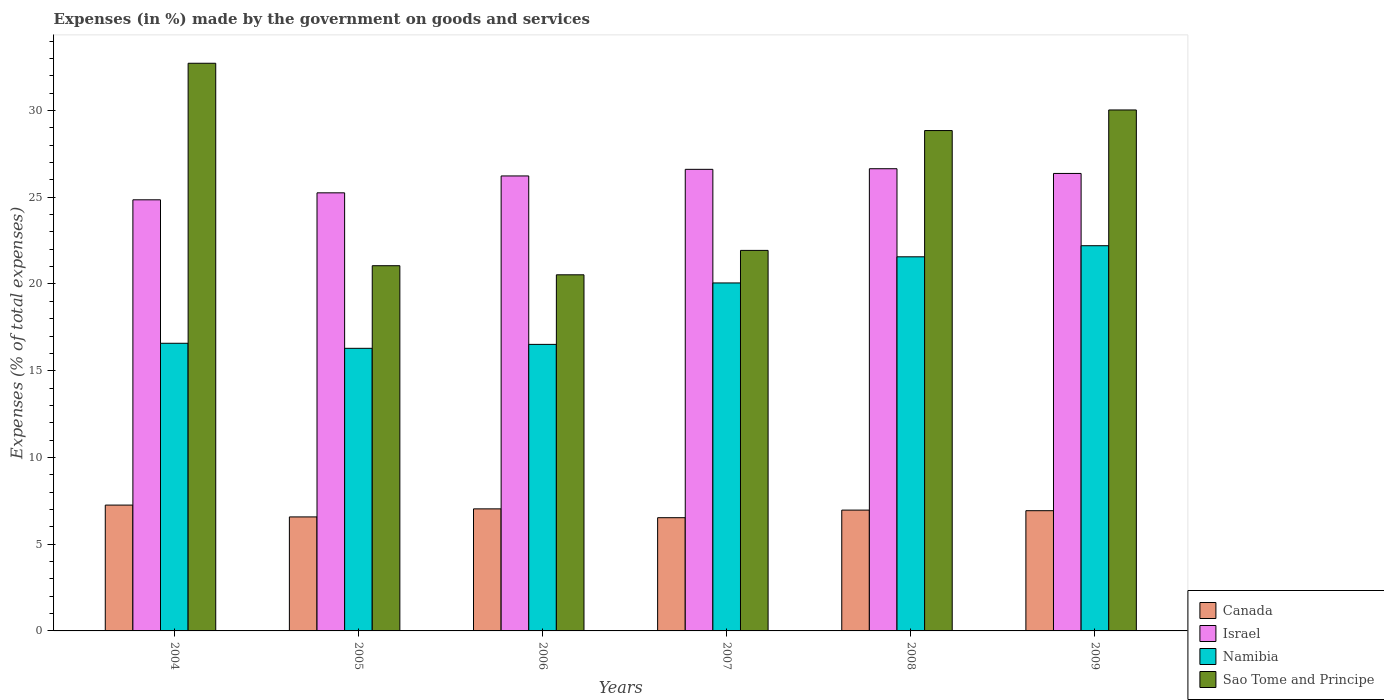How many different coloured bars are there?
Make the answer very short. 4. How many groups of bars are there?
Offer a terse response. 6. Are the number of bars per tick equal to the number of legend labels?
Offer a terse response. Yes. Are the number of bars on each tick of the X-axis equal?
Offer a terse response. Yes. How many bars are there on the 5th tick from the left?
Your answer should be compact. 4. What is the percentage of expenses made by the government on goods and services in Namibia in 2006?
Give a very brief answer. 16.52. Across all years, what is the maximum percentage of expenses made by the government on goods and services in Israel?
Ensure brevity in your answer.  26.65. Across all years, what is the minimum percentage of expenses made by the government on goods and services in Israel?
Your answer should be compact. 24.85. In which year was the percentage of expenses made by the government on goods and services in Israel minimum?
Ensure brevity in your answer.  2004. What is the total percentage of expenses made by the government on goods and services in Namibia in the graph?
Make the answer very short. 113.23. What is the difference between the percentage of expenses made by the government on goods and services in Namibia in 2004 and that in 2005?
Your answer should be compact. 0.29. What is the difference between the percentage of expenses made by the government on goods and services in Israel in 2008 and the percentage of expenses made by the government on goods and services in Canada in 2004?
Offer a very short reply. 19.39. What is the average percentage of expenses made by the government on goods and services in Sao Tome and Principe per year?
Provide a short and direct response. 25.85. In the year 2009, what is the difference between the percentage of expenses made by the government on goods and services in Sao Tome and Principe and percentage of expenses made by the government on goods and services in Israel?
Your answer should be compact. 3.66. What is the ratio of the percentage of expenses made by the government on goods and services in Israel in 2006 to that in 2007?
Offer a terse response. 0.99. Is the difference between the percentage of expenses made by the government on goods and services in Sao Tome and Principe in 2004 and 2007 greater than the difference between the percentage of expenses made by the government on goods and services in Israel in 2004 and 2007?
Ensure brevity in your answer.  Yes. What is the difference between the highest and the second highest percentage of expenses made by the government on goods and services in Canada?
Provide a short and direct response. 0.22. What is the difference between the highest and the lowest percentage of expenses made by the government on goods and services in Canada?
Ensure brevity in your answer.  0.73. What does the 1st bar from the left in 2007 represents?
Make the answer very short. Canada. What does the 4th bar from the right in 2006 represents?
Offer a very short reply. Canada. Is it the case that in every year, the sum of the percentage of expenses made by the government on goods and services in Israel and percentage of expenses made by the government on goods and services in Canada is greater than the percentage of expenses made by the government on goods and services in Namibia?
Make the answer very short. Yes. How many bars are there?
Ensure brevity in your answer.  24. How many years are there in the graph?
Provide a short and direct response. 6. What is the difference between two consecutive major ticks on the Y-axis?
Offer a terse response. 5. Where does the legend appear in the graph?
Make the answer very short. Bottom right. How many legend labels are there?
Provide a succinct answer. 4. What is the title of the graph?
Provide a succinct answer. Expenses (in %) made by the government on goods and services. What is the label or title of the Y-axis?
Your answer should be very brief. Expenses (% of total expenses). What is the Expenses (% of total expenses) in Canada in 2004?
Keep it short and to the point. 7.25. What is the Expenses (% of total expenses) of Israel in 2004?
Ensure brevity in your answer.  24.85. What is the Expenses (% of total expenses) in Namibia in 2004?
Give a very brief answer. 16.58. What is the Expenses (% of total expenses) of Sao Tome and Principe in 2004?
Offer a very short reply. 32.73. What is the Expenses (% of total expenses) of Canada in 2005?
Provide a short and direct response. 6.57. What is the Expenses (% of total expenses) in Israel in 2005?
Make the answer very short. 25.26. What is the Expenses (% of total expenses) of Namibia in 2005?
Give a very brief answer. 16.29. What is the Expenses (% of total expenses) in Sao Tome and Principe in 2005?
Your answer should be compact. 21.05. What is the Expenses (% of total expenses) of Canada in 2006?
Offer a terse response. 7.04. What is the Expenses (% of total expenses) in Israel in 2006?
Offer a very short reply. 26.23. What is the Expenses (% of total expenses) of Namibia in 2006?
Give a very brief answer. 16.52. What is the Expenses (% of total expenses) of Sao Tome and Principe in 2006?
Offer a terse response. 20.53. What is the Expenses (% of total expenses) of Canada in 2007?
Offer a terse response. 6.53. What is the Expenses (% of total expenses) of Israel in 2007?
Offer a terse response. 26.61. What is the Expenses (% of total expenses) of Namibia in 2007?
Your answer should be very brief. 20.06. What is the Expenses (% of total expenses) of Sao Tome and Principe in 2007?
Offer a terse response. 21.94. What is the Expenses (% of total expenses) in Canada in 2008?
Provide a short and direct response. 6.97. What is the Expenses (% of total expenses) of Israel in 2008?
Provide a short and direct response. 26.65. What is the Expenses (% of total expenses) of Namibia in 2008?
Make the answer very short. 21.57. What is the Expenses (% of total expenses) in Sao Tome and Principe in 2008?
Your response must be concise. 28.85. What is the Expenses (% of total expenses) of Canada in 2009?
Ensure brevity in your answer.  6.93. What is the Expenses (% of total expenses) in Israel in 2009?
Keep it short and to the point. 26.37. What is the Expenses (% of total expenses) in Namibia in 2009?
Ensure brevity in your answer.  22.21. What is the Expenses (% of total expenses) in Sao Tome and Principe in 2009?
Your answer should be compact. 30.03. Across all years, what is the maximum Expenses (% of total expenses) in Canada?
Your answer should be compact. 7.25. Across all years, what is the maximum Expenses (% of total expenses) of Israel?
Make the answer very short. 26.65. Across all years, what is the maximum Expenses (% of total expenses) in Namibia?
Your answer should be very brief. 22.21. Across all years, what is the maximum Expenses (% of total expenses) of Sao Tome and Principe?
Your answer should be compact. 32.73. Across all years, what is the minimum Expenses (% of total expenses) of Canada?
Ensure brevity in your answer.  6.53. Across all years, what is the minimum Expenses (% of total expenses) of Israel?
Ensure brevity in your answer.  24.85. Across all years, what is the minimum Expenses (% of total expenses) of Namibia?
Provide a succinct answer. 16.29. Across all years, what is the minimum Expenses (% of total expenses) in Sao Tome and Principe?
Offer a very short reply. 20.53. What is the total Expenses (% of total expenses) of Canada in the graph?
Provide a short and direct response. 41.29. What is the total Expenses (% of total expenses) in Israel in the graph?
Offer a terse response. 155.97. What is the total Expenses (% of total expenses) of Namibia in the graph?
Your answer should be compact. 113.23. What is the total Expenses (% of total expenses) in Sao Tome and Principe in the graph?
Ensure brevity in your answer.  155.13. What is the difference between the Expenses (% of total expenses) of Canada in 2004 and that in 2005?
Provide a succinct answer. 0.68. What is the difference between the Expenses (% of total expenses) in Israel in 2004 and that in 2005?
Your answer should be very brief. -0.4. What is the difference between the Expenses (% of total expenses) of Namibia in 2004 and that in 2005?
Provide a succinct answer. 0.29. What is the difference between the Expenses (% of total expenses) of Sao Tome and Principe in 2004 and that in 2005?
Your answer should be very brief. 11.67. What is the difference between the Expenses (% of total expenses) of Canada in 2004 and that in 2006?
Keep it short and to the point. 0.22. What is the difference between the Expenses (% of total expenses) of Israel in 2004 and that in 2006?
Provide a short and direct response. -1.38. What is the difference between the Expenses (% of total expenses) of Namibia in 2004 and that in 2006?
Make the answer very short. 0.06. What is the difference between the Expenses (% of total expenses) in Sao Tome and Principe in 2004 and that in 2006?
Your answer should be compact. 12.2. What is the difference between the Expenses (% of total expenses) of Canada in 2004 and that in 2007?
Give a very brief answer. 0.73. What is the difference between the Expenses (% of total expenses) in Israel in 2004 and that in 2007?
Provide a succinct answer. -1.76. What is the difference between the Expenses (% of total expenses) of Namibia in 2004 and that in 2007?
Provide a succinct answer. -3.48. What is the difference between the Expenses (% of total expenses) of Sao Tome and Principe in 2004 and that in 2007?
Make the answer very short. 10.79. What is the difference between the Expenses (% of total expenses) in Canada in 2004 and that in 2008?
Make the answer very short. 0.29. What is the difference between the Expenses (% of total expenses) of Israel in 2004 and that in 2008?
Your answer should be very brief. -1.79. What is the difference between the Expenses (% of total expenses) of Namibia in 2004 and that in 2008?
Provide a short and direct response. -4.98. What is the difference between the Expenses (% of total expenses) in Sao Tome and Principe in 2004 and that in 2008?
Provide a short and direct response. 3.88. What is the difference between the Expenses (% of total expenses) in Canada in 2004 and that in 2009?
Provide a succinct answer. 0.32. What is the difference between the Expenses (% of total expenses) of Israel in 2004 and that in 2009?
Provide a short and direct response. -1.52. What is the difference between the Expenses (% of total expenses) in Namibia in 2004 and that in 2009?
Offer a very short reply. -5.62. What is the difference between the Expenses (% of total expenses) in Sao Tome and Principe in 2004 and that in 2009?
Provide a short and direct response. 2.69. What is the difference between the Expenses (% of total expenses) in Canada in 2005 and that in 2006?
Make the answer very short. -0.46. What is the difference between the Expenses (% of total expenses) of Israel in 2005 and that in 2006?
Your answer should be very brief. -0.97. What is the difference between the Expenses (% of total expenses) in Namibia in 2005 and that in 2006?
Make the answer very short. -0.23. What is the difference between the Expenses (% of total expenses) of Sao Tome and Principe in 2005 and that in 2006?
Offer a very short reply. 0.52. What is the difference between the Expenses (% of total expenses) of Canada in 2005 and that in 2007?
Offer a terse response. 0.04. What is the difference between the Expenses (% of total expenses) in Israel in 2005 and that in 2007?
Provide a succinct answer. -1.35. What is the difference between the Expenses (% of total expenses) in Namibia in 2005 and that in 2007?
Your response must be concise. -3.77. What is the difference between the Expenses (% of total expenses) in Sao Tome and Principe in 2005 and that in 2007?
Offer a terse response. -0.88. What is the difference between the Expenses (% of total expenses) in Canada in 2005 and that in 2008?
Your answer should be very brief. -0.39. What is the difference between the Expenses (% of total expenses) in Israel in 2005 and that in 2008?
Provide a succinct answer. -1.39. What is the difference between the Expenses (% of total expenses) in Namibia in 2005 and that in 2008?
Make the answer very short. -5.28. What is the difference between the Expenses (% of total expenses) of Sao Tome and Principe in 2005 and that in 2008?
Give a very brief answer. -7.79. What is the difference between the Expenses (% of total expenses) of Canada in 2005 and that in 2009?
Give a very brief answer. -0.36. What is the difference between the Expenses (% of total expenses) in Israel in 2005 and that in 2009?
Offer a very short reply. -1.12. What is the difference between the Expenses (% of total expenses) of Namibia in 2005 and that in 2009?
Give a very brief answer. -5.92. What is the difference between the Expenses (% of total expenses) in Sao Tome and Principe in 2005 and that in 2009?
Ensure brevity in your answer.  -8.98. What is the difference between the Expenses (% of total expenses) of Canada in 2006 and that in 2007?
Your response must be concise. 0.51. What is the difference between the Expenses (% of total expenses) in Israel in 2006 and that in 2007?
Provide a short and direct response. -0.38. What is the difference between the Expenses (% of total expenses) of Namibia in 2006 and that in 2007?
Provide a short and direct response. -3.54. What is the difference between the Expenses (% of total expenses) of Sao Tome and Principe in 2006 and that in 2007?
Keep it short and to the point. -1.41. What is the difference between the Expenses (% of total expenses) of Canada in 2006 and that in 2008?
Your answer should be compact. 0.07. What is the difference between the Expenses (% of total expenses) of Israel in 2006 and that in 2008?
Ensure brevity in your answer.  -0.42. What is the difference between the Expenses (% of total expenses) in Namibia in 2006 and that in 2008?
Give a very brief answer. -5.05. What is the difference between the Expenses (% of total expenses) of Sao Tome and Principe in 2006 and that in 2008?
Provide a short and direct response. -8.32. What is the difference between the Expenses (% of total expenses) in Canada in 2006 and that in 2009?
Offer a very short reply. 0.11. What is the difference between the Expenses (% of total expenses) in Israel in 2006 and that in 2009?
Give a very brief answer. -0.14. What is the difference between the Expenses (% of total expenses) in Namibia in 2006 and that in 2009?
Make the answer very short. -5.69. What is the difference between the Expenses (% of total expenses) in Sao Tome and Principe in 2006 and that in 2009?
Keep it short and to the point. -9.5. What is the difference between the Expenses (% of total expenses) of Canada in 2007 and that in 2008?
Your response must be concise. -0.44. What is the difference between the Expenses (% of total expenses) of Israel in 2007 and that in 2008?
Offer a terse response. -0.04. What is the difference between the Expenses (% of total expenses) in Namibia in 2007 and that in 2008?
Your answer should be very brief. -1.51. What is the difference between the Expenses (% of total expenses) of Sao Tome and Principe in 2007 and that in 2008?
Offer a very short reply. -6.91. What is the difference between the Expenses (% of total expenses) of Canada in 2007 and that in 2009?
Your answer should be very brief. -0.4. What is the difference between the Expenses (% of total expenses) of Israel in 2007 and that in 2009?
Your response must be concise. 0.24. What is the difference between the Expenses (% of total expenses) of Namibia in 2007 and that in 2009?
Make the answer very short. -2.15. What is the difference between the Expenses (% of total expenses) in Sao Tome and Principe in 2007 and that in 2009?
Your answer should be compact. -8.1. What is the difference between the Expenses (% of total expenses) in Canada in 2008 and that in 2009?
Offer a terse response. 0.03. What is the difference between the Expenses (% of total expenses) in Israel in 2008 and that in 2009?
Offer a very short reply. 0.27. What is the difference between the Expenses (% of total expenses) of Namibia in 2008 and that in 2009?
Offer a terse response. -0.64. What is the difference between the Expenses (% of total expenses) in Sao Tome and Principe in 2008 and that in 2009?
Ensure brevity in your answer.  -1.19. What is the difference between the Expenses (% of total expenses) in Canada in 2004 and the Expenses (% of total expenses) in Israel in 2005?
Offer a terse response. -18. What is the difference between the Expenses (% of total expenses) in Canada in 2004 and the Expenses (% of total expenses) in Namibia in 2005?
Ensure brevity in your answer.  -9.04. What is the difference between the Expenses (% of total expenses) in Canada in 2004 and the Expenses (% of total expenses) in Sao Tome and Principe in 2005?
Your answer should be compact. -13.8. What is the difference between the Expenses (% of total expenses) of Israel in 2004 and the Expenses (% of total expenses) of Namibia in 2005?
Provide a short and direct response. 8.56. What is the difference between the Expenses (% of total expenses) in Israel in 2004 and the Expenses (% of total expenses) in Sao Tome and Principe in 2005?
Offer a terse response. 3.8. What is the difference between the Expenses (% of total expenses) in Namibia in 2004 and the Expenses (% of total expenses) in Sao Tome and Principe in 2005?
Make the answer very short. -4.47. What is the difference between the Expenses (% of total expenses) in Canada in 2004 and the Expenses (% of total expenses) in Israel in 2006?
Your answer should be very brief. -18.98. What is the difference between the Expenses (% of total expenses) in Canada in 2004 and the Expenses (% of total expenses) in Namibia in 2006?
Keep it short and to the point. -9.26. What is the difference between the Expenses (% of total expenses) in Canada in 2004 and the Expenses (% of total expenses) in Sao Tome and Principe in 2006?
Your answer should be very brief. -13.28. What is the difference between the Expenses (% of total expenses) in Israel in 2004 and the Expenses (% of total expenses) in Namibia in 2006?
Your response must be concise. 8.33. What is the difference between the Expenses (% of total expenses) in Israel in 2004 and the Expenses (% of total expenses) in Sao Tome and Principe in 2006?
Provide a succinct answer. 4.32. What is the difference between the Expenses (% of total expenses) in Namibia in 2004 and the Expenses (% of total expenses) in Sao Tome and Principe in 2006?
Offer a very short reply. -3.95. What is the difference between the Expenses (% of total expenses) of Canada in 2004 and the Expenses (% of total expenses) of Israel in 2007?
Your answer should be compact. -19.36. What is the difference between the Expenses (% of total expenses) in Canada in 2004 and the Expenses (% of total expenses) in Namibia in 2007?
Keep it short and to the point. -12.81. What is the difference between the Expenses (% of total expenses) in Canada in 2004 and the Expenses (% of total expenses) in Sao Tome and Principe in 2007?
Offer a terse response. -14.68. What is the difference between the Expenses (% of total expenses) of Israel in 2004 and the Expenses (% of total expenses) of Namibia in 2007?
Offer a very short reply. 4.79. What is the difference between the Expenses (% of total expenses) of Israel in 2004 and the Expenses (% of total expenses) of Sao Tome and Principe in 2007?
Give a very brief answer. 2.92. What is the difference between the Expenses (% of total expenses) of Namibia in 2004 and the Expenses (% of total expenses) of Sao Tome and Principe in 2007?
Your response must be concise. -5.35. What is the difference between the Expenses (% of total expenses) in Canada in 2004 and the Expenses (% of total expenses) in Israel in 2008?
Give a very brief answer. -19.39. What is the difference between the Expenses (% of total expenses) of Canada in 2004 and the Expenses (% of total expenses) of Namibia in 2008?
Your answer should be compact. -14.31. What is the difference between the Expenses (% of total expenses) of Canada in 2004 and the Expenses (% of total expenses) of Sao Tome and Principe in 2008?
Provide a succinct answer. -21.59. What is the difference between the Expenses (% of total expenses) in Israel in 2004 and the Expenses (% of total expenses) in Namibia in 2008?
Provide a short and direct response. 3.29. What is the difference between the Expenses (% of total expenses) of Israel in 2004 and the Expenses (% of total expenses) of Sao Tome and Principe in 2008?
Offer a terse response. -3.99. What is the difference between the Expenses (% of total expenses) in Namibia in 2004 and the Expenses (% of total expenses) in Sao Tome and Principe in 2008?
Provide a succinct answer. -12.26. What is the difference between the Expenses (% of total expenses) of Canada in 2004 and the Expenses (% of total expenses) of Israel in 2009?
Offer a very short reply. -19.12. What is the difference between the Expenses (% of total expenses) of Canada in 2004 and the Expenses (% of total expenses) of Namibia in 2009?
Provide a succinct answer. -14.95. What is the difference between the Expenses (% of total expenses) of Canada in 2004 and the Expenses (% of total expenses) of Sao Tome and Principe in 2009?
Make the answer very short. -22.78. What is the difference between the Expenses (% of total expenses) of Israel in 2004 and the Expenses (% of total expenses) of Namibia in 2009?
Your answer should be very brief. 2.65. What is the difference between the Expenses (% of total expenses) of Israel in 2004 and the Expenses (% of total expenses) of Sao Tome and Principe in 2009?
Your answer should be compact. -5.18. What is the difference between the Expenses (% of total expenses) in Namibia in 2004 and the Expenses (% of total expenses) in Sao Tome and Principe in 2009?
Your answer should be very brief. -13.45. What is the difference between the Expenses (% of total expenses) of Canada in 2005 and the Expenses (% of total expenses) of Israel in 2006?
Your answer should be compact. -19.66. What is the difference between the Expenses (% of total expenses) in Canada in 2005 and the Expenses (% of total expenses) in Namibia in 2006?
Your response must be concise. -9.95. What is the difference between the Expenses (% of total expenses) of Canada in 2005 and the Expenses (% of total expenses) of Sao Tome and Principe in 2006?
Provide a short and direct response. -13.96. What is the difference between the Expenses (% of total expenses) of Israel in 2005 and the Expenses (% of total expenses) of Namibia in 2006?
Your answer should be very brief. 8.74. What is the difference between the Expenses (% of total expenses) in Israel in 2005 and the Expenses (% of total expenses) in Sao Tome and Principe in 2006?
Provide a succinct answer. 4.73. What is the difference between the Expenses (% of total expenses) of Namibia in 2005 and the Expenses (% of total expenses) of Sao Tome and Principe in 2006?
Ensure brevity in your answer.  -4.24. What is the difference between the Expenses (% of total expenses) in Canada in 2005 and the Expenses (% of total expenses) in Israel in 2007?
Give a very brief answer. -20.04. What is the difference between the Expenses (% of total expenses) of Canada in 2005 and the Expenses (% of total expenses) of Namibia in 2007?
Offer a very short reply. -13.49. What is the difference between the Expenses (% of total expenses) in Canada in 2005 and the Expenses (% of total expenses) in Sao Tome and Principe in 2007?
Ensure brevity in your answer.  -15.36. What is the difference between the Expenses (% of total expenses) of Israel in 2005 and the Expenses (% of total expenses) of Namibia in 2007?
Offer a very short reply. 5.19. What is the difference between the Expenses (% of total expenses) of Israel in 2005 and the Expenses (% of total expenses) of Sao Tome and Principe in 2007?
Keep it short and to the point. 3.32. What is the difference between the Expenses (% of total expenses) of Namibia in 2005 and the Expenses (% of total expenses) of Sao Tome and Principe in 2007?
Your answer should be very brief. -5.65. What is the difference between the Expenses (% of total expenses) in Canada in 2005 and the Expenses (% of total expenses) in Israel in 2008?
Your response must be concise. -20.07. What is the difference between the Expenses (% of total expenses) of Canada in 2005 and the Expenses (% of total expenses) of Namibia in 2008?
Offer a very short reply. -14.99. What is the difference between the Expenses (% of total expenses) of Canada in 2005 and the Expenses (% of total expenses) of Sao Tome and Principe in 2008?
Give a very brief answer. -22.27. What is the difference between the Expenses (% of total expenses) in Israel in 2005 and the Expenses (% of total expenses) in Namibia in 2008?
Give a very brief answer. 3.69. What is the difference between the Expenses (% of total expenses) in Israel in 2005 and the Expenses (% of total expenses) in Sao Tome and Principe in 2008?
Provide a succinct answer. -3.59. What is the difference between the Expenses (% of total expenses) in Namibia in 2005 and the Expenses (% of total expenses) in Sao Tome and Principe in 2008?
Make the answer very short. -12.55. What is the difference between the Expenses (% of total expenses) of Canada in 2005 and the Expenses (% of total expenses) of Israel in 2009?
Provide a succinct answer. -19.8. What is the difference between the Expenses (% of total expenses) of Canada in 2005 and the Expenses (% of total expenses) of Namibia in 2009?
Ensure brevity in your answer.  -15.63. What is the difference between the Expenses (% of total expenses) in Canada in 2005 and the Expenses (% of total expenses) in Sao Tome and Principe in 2009?
Offer a very short reply. -23.46. What is the difference between the Expenses (% of total expenses) of Israel in 2005 and the Expenses (% of total expenses) of Namibia in 2009?
Your answer should be very brief. 3.05. What is the difference between the Expenses (% of total expenses) of Israel in 2005 and the Expenses (% of total expenses) of Sao Tome and Principe in 2009?
Ensure brevity in your answer.  -4.78. What is the difference between the Expenses (% of total expenses) of Namibia in 2005 and the Expenses (% of total expenses) of Sao Tome and Principe in 2009?
Offer a terse response. -13.74. What is the difference between the Expenses (% of total expenses) in Canada in 2006 and the Expenses (% of total expenses) in Israel in 2007?
Ensure brevity in your answer.  -19.57. What is the difference between the Expenses (% of total expenses) in Canada in 2006 and the Expenses (% of total expenses) in Namibia in 2007?
Your response must be concise. -13.02. What is the difference between the Expenses (% of total expenses) of Canada in 2006 and the Expenses (% of total expenses) of Sao Tome and Principe in 2007?
Offer a terse response. -14.9. What is the difference between the Expenses (% of total expenses) in Israel in 2006 and the Expenses (% of total expenses) in Namibia in 2007?
Provide a short and direct response. 6.17. What is the difference between the Expenses (% of total expenses) in Israel in 2006 and the Expenses (% of total expenses) in Sao Tome and Principe in 2007?
Offer a very short reply. 4.29. What is the difference between the Expenses (% of total expenses) of Namibia in 2006 and the Expenses (% of total expenses) of Sao Tome and Principe in 2007?
Make the answer very short. -5.42. What is the difference between the Expenses (% of total expenses) in Canada in 2006 and the Expenses (% of total expenses) in Israel in 2008?
Provide a short and direct response. -19.61. What is the difference between the Expenses (% of total expenses) of Canada in 2006 and the Expenses (% of total expenses) of Namibia in 2008?
Offer a very short reply. -14.53. What is the difference between the Expenses (% of total expenses) in Canada in 2006 and the Expenses (% of total expenses) in Sao Tome and Principe in 2008?
Your answer should be compact. -21.81. What is the difference between the Expenses (% of total expenses) of Israel in 2006 and the Expenses (% of total expenses) of Namibia in 2008?
Your answer should be very brief. 4.66. What is the difference between the Expenses (% of total expenses) in Israel in 2006 and the Expenses (% of total expenses) in Sao Tome and Principe in 2008?
Provide a short and direct response. -2.62. What is the difference between the Expenses (% of total expenses) in Namibia in 2006 and the Expenses (% of total expenses) in Sao Tome and Principe in 2008?
Give a very brief answer. -12.33. What is the difference between the Expenses (% of total expenses) in Canada in 2006 and the Expenses (% of total expenses) in Israel in 2009?
Ensure brevity in your answer.  -19.34. What is the difference between the Expenses (% of total expenses) of Canada in 2006 and the Expenses (% of total expenses) of Namibia in 2009?
Provide a short and direct response. -15.17. What is the difference between the Expenses (% of total expenses) in Canada in 2006 and the Expenses (% of total expenses) in Sao Tome and Principe in 2009?
Give a very brief answer. -23. What is the difference between the Expenses (% of total expenses) of Israel in 2006 and the Expenses (% of total expenses) of Namibia in 2009?
Provide a succinct answer. 4.02. What is the difference between the Expenses (% of total expenses) in Israel in 2006 and the Expenses (% of total expenses) in Sao Tome and Principe in 2009?
Your answer should be compact. -3.8. What is the difference between the Expenses (% of total expenses) of Namibia in 2006 and the Expenses (% of total expenses) of Sao Tome and Principe in 2009?
Provide a succinct answer. -13.51. What is the difference between the Expenses (% of total expenses) in Canada in 2007 and the Expenses (% of total expenses) in Israel in 2008?
Offer a terse response. -20.12. What is the difference between the Expenses (% of total expenses) in Canada in 2007 and the Expenses (% of total expenses) in Namibia in 2008?
Your response must be concise. -15.04. What is the difference between the Expenses (% of total expenses) in Canada in 2007 and the Expenses (% of total expenses) in Sao Tome and Principe in 2008?
Your answer should be compact. -22.32. What is the difference between the Expenses (% of total expenses) of Israel in 2007 and the Expenses (% of total expenses) of Namibia in 2008?
Ensure brevity in your answer.  5.04. What is the difference between the Expenses (% of total expenses) in Israel in 2007 and the Expenses (% of total expenses) in Sao Tome and Principe in 2008?
Your response must be concise. -2.24. What is the difference between the Expenses (% of total expenses) in Namibia in 2007 and the Expenses (% of total expenses) in Sao Tome and Principe in 2008?
Your response must be concise. -8.78. What is the difference between the Expenses (% of total expenses) of Canada in 2007 and the Expenses (% of total expenses) of Israel in 2009?
Provide a short and direct response. -19.85. What is the difference between the Expenses (% of total expenses) in Canada in 2007 and the Expenses (% of total expenses) in Namibia in 2009?
Your response must be concise. -15.68. What is the difference between the Expenses (% of total expenses) in Canada in 2007 and the Expenses (% of total expenses) in Sao Tome and Principe in 2009?
Ensure brevity in your answer.  -23.51. What is the difference between the Expenses (% of total expenses) in Israel in 2007 and the Expenses (% of total expenses) in Namibia in 2009?
Provide a succinct answer. 4.4. What is the difference between the Expenses (% of total expenses) of Israel in 2007 and the Expenses (% of total expenses) of Sao Tome and Principe in 2009?
Give a very brief answer. -3.42. What is the difference between the Expenses (% of total expenses) in Namibia in 2007 and the Expenses (% of total expenses) in Sao Tome and Principe in 2009?
Your answer should be compact. -9.97. What is the difference between the Expenses (% of total expenses) of Canada in 2008 and the Expenses (% of total expenses) of Israel in 2009?
Give a very brief answer. -19.41. What is the difference between the Expenses (% of total expenses) of Canada in 2008 and the Expenses (% of total expenses) of Namibia in 2009?
Your response must be concise. -15.24. What is the difference between the Expenses (% of total expenses) in Canada in 2008 and the Expenses (% of total expenses) in Sao Tome and Principe in 2009?
Ensure brevity in your answer.  -23.07. What is the difference between the Expenses (% of total expenses) in Israel in 2008 and the Expenses (% of total expenses) in Namibia in 2009?
Your response must be concise. 4.44. What is the difference between the Expenses (% of total expenses) of Israel in 2008 and the Expenses (% of total expenses) of Sao Tome and Principe in 2009?
Offer a terse response. -3.39. What is the difference between the Expenses (% of total expenses) of Namibia in 2008 and the Expenses (% of total expenses) of Sao Tome and Principe in 2009?
Your response must be concise. -8.47. What is the average Expenses (% of total expenses) of Canada per year?
Ensure brevity in your answer.  6.88. What is the average Expenses (% of total expenses) of Israel per year?
Ensure brevity in your answer.  25.99. What is the average Expenses (% of total expenses) of Namibia per year?
Provide a short and direct response. 18.87. What is the average Expenses (% of total expenses) of Sao Tome and Principe per year?
Make the answer very short. 25.85. In the year 2004, what is the difference between the Expenses (% of total expenses) in Canada and Expenses (% of total expenses) in Israel?
Keep it short and to the point. -17.6. In the year 2004, what is the difference between the Expenses (% of total expenses) in Canada and Expenses (% of total expenses) in Namibia?
Your answer should be very brief. -9.33. In the year 2004, what is the difference between the Expenses (% of total expenses) in Canada and Expenses (% of total expenses) in Sao Tome and Principe?
Provide a succinct answer. -25.47. In the year 2004, what is the difference between the Expenses (% of total expenses) of Israel and Expenses (% of total expenses) of Namibia?
Give a very brief answer. 8.27. In the year 2004, what is the difference between the Expenses (% of total expenses) of Israel and Expenses (% of total expenses) of Sao Tome and Principe?
Offer a very short reply. -7.87. In the year 2004, what is the difference between the Expenses (% of total expenses) of Namibia and Expenses (% of total expenses) of Sao Tome and Principe?
Offer a very short reply. -16.14. In the year 2005, what is the difference between the Expenses (% of total expenses) in Canada and Expenses (% of total expenses) in Israel?
Your response must be concise. -18.68. In the year 2005, what is the difference between the Expenses (% of total expenses) of Canada and Expenses (% of total expenses) of Namibia?
Give a very brief answer. -9.72. In the year 2005, what is the difference between the Expenses (% of total expenses) in Canada and Expenses (% of total expenses) in Sao Tome and Principe?
Your response must be concise. -14.48. In the year 2005, what is the difference between the Expenses (% of total expenses) in Israel and Expenses (% of total expenses) in Namibia?
Ensure brevity in your answer.  8.96. In the year 2005, what is the difference between the Expenses (% of total expenses) in Israel and Expenses (% of total expenses) in Sao Tome and Principe?
Your answer should be very brief. 4.2. In the year 2005, what is the difference between the Expenses (% of total expenses) in Namibia and Expenses (% of total expenses) in Sao Tome and Principe?
Your answer should be compact. -4.76. In the year 2006, what is the difference between the Expenses (% of total expenses) in Canada and Expenses (% of total expenses) in Israel?
Offer a terse response. -19.19. In the year 2006, what is the difference between the Expenses (% of total expenses) in Canada and Expenses (% of total expenses) in Namibia?
Keep it short and to the point. -9.48. In the year 2006, what is the difference between the Expenses (% of total expenses) in Canada and Expenses (% of total expenses) in Sao Tome and Principe?
Provide a succinct answer. -13.49. In the year 2006, what is the difference between the Expenses (% of total expenses) in Israel and Expenses (% of total expenses) in Namibia?
Keep it short and to the point. 9.71. In the year 2006, what is the difference between the Expenses (% of total expenses) in Israel and Expenses (% of total expenses) in Sao Tome and Principe?
Make the answer very short. 5.7. In the year 2006, what is the difference between the Expenses (% of total expenses) in Namibia and Expenses (% of total expenses) in Sao Tome and Principe?
Your answer should be compact. -4.01. In the year 2007, what is the difference between the Expenses (% of total expenses) in Canada and Expenses (% of total expenses) in Israel?
Offer a terse response. -20.08. In the year 2007, what is the difference between the Expenses (% of total expenses) in Canada and Expenses (% of total expenses) in Namibia?
Your answer should be compact. -13.53. In the year 2007, what is the difference between the Expenses (% of total expenses) in Canada and Expenses (% of total expenses) in Sao Tome and Principe?
Keep it short and to the point. -15.41. In the year 2007, what is the difference between the Expenses (% of total expenses) in Israel and Expenses (% of total expenses) in Namibia?
Make the answer very short. 6.55. In the year 2007, what is the difference between the Expenses (% of total expenses) of Israel and Expenses (% of total expenses) of Sao Tome and Principe?
Your response must be concise. 4.67. In the year 2007, what is the difference between the Expenses (% of total expenses) in Namibia and Expenses (% of total expenses) in Sao Tome and Principe?
Your response must be concise. -1.88. In the year 2008, what is the difference between the Expenses (% of total expenses) of Canada and Expenses (% of total expenses) of Israel?
Your response must be concise. -19.68. In the year 2008, what is the difference between the Expenses (% of total expenses) of Canada and Expenses (% of total expenses) of Namibia?
Offer a terse response. -14.6. In the year 2008, what is the difference between the Expenses (% of total expenses) of Canada and Expenses (% of total expenses) of Sao Tome and Principe?
Offer a terse response. -21.88. In the year 2008, what is the difference between the Expenses (% of total expenses) of Israel and Expenses (% of total expenses) of Namibia?
Ensure brevity in your answer.  5.08. In the year 2008, what is the difference between the Expenses (% of total expenses) in Israel and Expenses (% of total expenses) in Sao Tome and Principe?
Provide a short and direct response. -2.2. In the year 2008, what is the difference between the Expenses (% of total expenses) of Namibia and Expenses (% of total expenses) of Sao Tome and Principe?
Offer a very short reply. -7.28. In the year 2009, what is the difference between the Expenses (% of total expenses) of Canada and Expenses (% of total expenses) of Israel?
Your answer should be very brief. -19.44. In the year 2009, what is the difference between the Expenses (% of total expenses) in Canada and Expenses (% of total expenses) in Namibia?
Give a very brief answer. -15.28. In the year 2009, what is the difference between the Expenses (% of total expenses) of Canada and Expenses (% of total expenses) of Sao Tome and Principe?
Provide a succinct answer. -23.1. In the year 2009, what is the difference between the Expenses (% of total expenses) in Israel and Expenses (% of total expenses) in Namibia?
Give a very brief answer. 4.17. In the year 2009, what is the difference between the Expenses (% of total expenses) of Israel and Expenses (% of total expenses) of Sao Tome and Principe?
Your answer should be very brief. -3.66. In the year 2009, what is the difference between the Expenses (% of total expenses) of Namibia and Expenses (% of total expenses) of Sao Tome and Principe?
Ensure brevity in your answer.  -7.83. What is the ratio of the Expenses (% of total expenses) in Canada in 2004 to that in 2005?
Provide a short and direct response. 1.1. What is the ratio of the Expenses (% of total expenses) of Israel in 2004 to that in 2005?
Ensure brevity in your answer.  0.98. What is the ratio of the Expenses (% of total expenses) in Namibia in 2004 to that in 2005?
Provide a short and direct response. 1.02. What is the ratio of the Expenses (% of total expenses) in Sao Tome and Principe in 2004 to that in 2005?
Offer a very short reply. 1.55. What is the ratio of the Expenses (% of total expenses) of Canada in 2004 to that in 2006?
Your answer should be compact. 1.03. What is the ratio of the Expenses (% of total expenses) in Israel in 2004 to that in 2006?
Offer a terse response. 0.95. What is the ratio of the Expenses (% of total expenses) in Sao Tome and Principe in 2004 to that in 2006?
Your answer should be very brief. 1.59. What is the ratio of the Expenses (% of total expenses) in Canada in 2004 to that in 2007?
Ensure brevity in your answer.  1.11. What is the ratio of the Expenses (% of total expenses) in Israel in 2004 to that in 2007?
Ensure brevity in your answer.  0.93. What is the ratio of the Expenses (% of total expenses) of Namibia in 2004 to that in 2007?
Keep it short and to the point. 0.83. What is the ratio of the Expenses (% of total expenses) of Sao Tome and Principe in 2004 to that in 2007?
Your answer should be compact. 1.49. What is the ratio of the Expenses (% of total expenses) in Canada in 2004 to that in 2008?
Provide a succinct answer. 1.04. What is the ratio of the Expenses (% of total expenses) in Israel in 2004 to that in 2008?
Offer a very short reply. 0.93. What is the ratio of the Expenses (% of total expenses) of Namibia in 2004 to that in 2008?
Your answer should be compact. 0.77. What is the ratio of the Expenses (% of total expenses) of Sao Tome and Principe in 2004 to that in 2008?
Ensure brevity in your answer.  1.13. What is the ratio of the Expenses (% of total expenses) of Canada in 2004 to that in 2009?
Provide a short and direct response. 1.05. What is the ratio of the Expenses (% of total expenses) of Israel in 2004 to that in 2009?
Your answer should be compact. 0.94. What is the ratio of the Expenses (% of total expenses) of Namibia in 2004 to that in 2009?
Give a very brief answer. 0.75. What is the ratio of the Expenses (% of total expenses) of Sao Tome and Principe in 2004 to that in 2009?
Offer a very short reply. 1.09. What is the ratio of the Expenses (% of total expenses) in Canada in 2005 to that in 2006?
Provide a succinct answer. 0.93. What is the ratio of the Expenses (% of total expenses) in Israel in 2005 to that in 2006?
Provide a short and direct response. 0.96. What is the ratio of the Expenses (% of total expenses) in Namibia in 2005 to that in 2006?
Provide a short and direct response. 0.99. What is the ratio of the Expenses (% of total expenses) in Sao Tome and Principe in 2005 to that in 2006?
Make the answer very short. 1.03. What is the ratio of the Expenses (% of total expenses) of Canada in 2005 to that in 2007?
Give a very brief answer. 1.01. What is the ratio of the Expenses (% of total expenses) of Israel in 2005 to that in 2007?
Ensure brevity in your answer.  0.95. What is the ratio of the Expenses (% of total expenses) of Namibia in 2005 to that in 2007?
Give a very brief answer. 0.81. What is the ratio of the Expenses (% of total expenses) of Sao Tome and Principe in 2005 to that in 2007?
Ensure brevity in your answer.  0.96. What is the ratio of the Expenses (% of total expenses) of Canada in 2005 to that in 2008?
Offer a terse response. 0.94. What is the ratio of the Expenses (% of total expenses) in Israel in 2005 to that in 2008?
Provide a succinct answer. 0.95. What is the ratio of the Expenses (% of total expenses) in Namibia in 2005 to that in 2008?
Your answer should be very brief. 0.76. What is the ratio of the Expenses (% of total expenses) in Sao Tome and Principe in 2005 to that in 2008?
Provide a succinct answer. 0.73. What is the ratio of the Expenses (% of total expenses) of Canada in 2005 to that in 2009?
Provide a short and direct response. 0.95. What is the ratio of the Expenses (% of total expenses) of Israel in 2005 to that in 2009?
Offer a terse response. 0.96. What is the ratio of the Expenses (% of total expenses) in Namibia in 2005 to that in 2009?
Provide a succinct answer. 0.73. What is the ratio of the Expenses (% of total expenses) in Sao Tome and Principe in 2005 to that in 2009?
Offer a terse response. 0.7. What is the ratio of the Expenses (% of total expenses) in Canada in 2006 to that in 2007?
Your answer should be very brief. 1.08. What is the ratio of the Expenses (% of total expenses) in Israel in 2006 to that in 2007?
Your answer should be compact. 0.99. What is the ratio of the Expenses (% of total expenses) in Namibia in 2006 to that in 2007?
Provide a succinct answer. 0.82. What is the ratio of the Expenses (% of total expenses) in Sao Tome and Principe in 2006 to that in 2007?
Offer a terse response. 0.94. What is the ratio of the Expenses (% of total expenses) of Canada in 2006 to that in 2008?
Provide a succinct answer. 1.01. What is the ratio of the Expenses (% of total expenses) in Israel in 2006 to that in 2008?
Make the answer very short. 0.98. What is the ratio of the Expenses (% of total expenses) of Namibia in 2006 to that in 2008?
Offer a very short reply. 0.77. What is the ratio of the Expenses (% of total expenses) of Sao Tome and Principe in 2006 to that in 2008?
Keep it short and to the point. 0.71. What is the ratio of the Expenses (% of total expenses) of Canada in 2006 to that in 2009?
Make the answer very short. 1.02. What is the ratio of the Expenses (% of total expenses) of Israel in 2006 to that in 2009?
Keep it short and to the point. 0.99. What is the ratio of the Expenses (% of total expenses) of Namibia in 2006 to that in 2009?
Ensure brevity in your answer.  0.74. What is the ratio of the Expenses (% of total expenses) of Sao Tome and Principe in 2006 to that in 2009?
Give a very brief answer. 0.68. What is the ratio of the Expenses (% of total expenses) in Canada in 2007 to that in 2008?
Offer a terse response. 0.94. What is the ratio of the Expenses (% of total expenses) in Israel in 2007 to that in 2008?
Keep it short and to the point. 1. What is the ratio of the Expenses (% of total expenses) of Namibia in 2007 to that in 2008?
Ensure brevity in your answer.  0.93. What is the ratio of the Expenses (% of total expenses) in Sao Tome and Principe in 2007 to that in 2008?
Make the answer very short. 0.76. What is the ratio of the Expenses (% of total expenses) of Canada in 2007 to that in 2009?
Your answer should be very brief. 0.94. What is the ratio of the Expenses (% of total expenses) in Namibia in 2007 to that in 2009?
Offer a terse response. 0.9. What is the ratio of the Expenses (% of total expenses) in Sao Tome and Principe in 2007 to that in 2009?
Keep it short and to the point. 0.73. What is the ratio of the Expenses (% of total expenses) in Israel in 2008 to that in 2009?
Keep it short and to the point. 1.01. What is the ratio of the Expenses (% of total expenses) in Namibia in 2008 to that in 2009?
Ensure brevity in your answer.  0.97. What is the ratio of the Expenses (% of total expenses) of Sao Tome and Principe in 2008 to that in 2009?
Offer a very short reply. 0.96. What is the difference between the highest and the second highest Expenses (% of total expenses) in Canada?
Provide a short and direct response. 0.22. What is the difference between the highest and the second highest Expenses (% of total expenses) in Israel?
Make the answer very short. 0.04. What is the difference between the highest and the second highest Expenses (% of total expenses) of Namibia?
Make the answer very short. 0.64. What is the difference between the highest and the second highest Expenses (% of total expenses) in Sao Tome and Principe?
Provide a short and direct response. 2.69. What is the difference between the highest and the lowest Expenses (% of total expenses) in Canada?
Your answer should be very brief. 0.73. What is the difference between the highest and the lowest Expenses (% of total expenses) in Israel?
Provide a short and direct response. 1.79. What is the difference between the highest and the lowest Expenses (% of total expenses) of Namibia?
Make the answer very short. 5.92. What is the difference between the highest and the lowest Expenses (% of total expenses) in Sao Tome and Principe?
Make the answer very short. 12.2. 